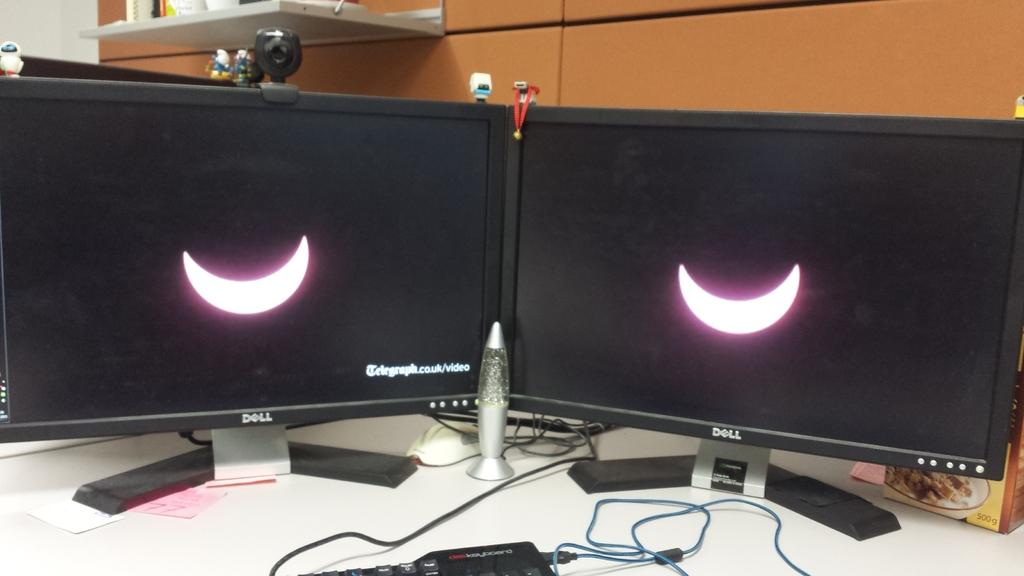<image>
Summarize the visual content of the image. A pair of Dell monitors with crescent moons showing on them. 